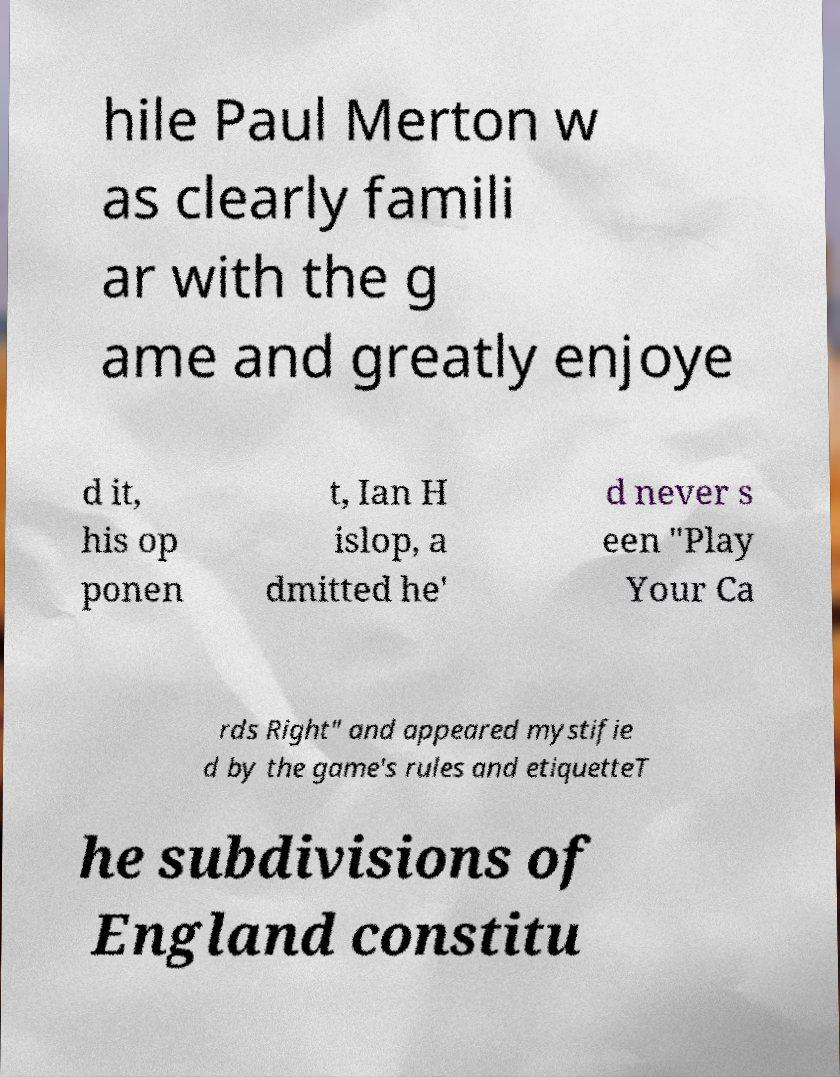What messages or text are displayed in this image? I need them in a readable, typed format. hile Paul Merton w as clearly famili ar with the g ame and greatly enjoye d it, his op ponen t, Ian H islop, a dmitted he' d never s een "Play Your Ca rds Right" and appeared mystifie d by the game's rules and etiquetteT he subdivisions of England constitu 